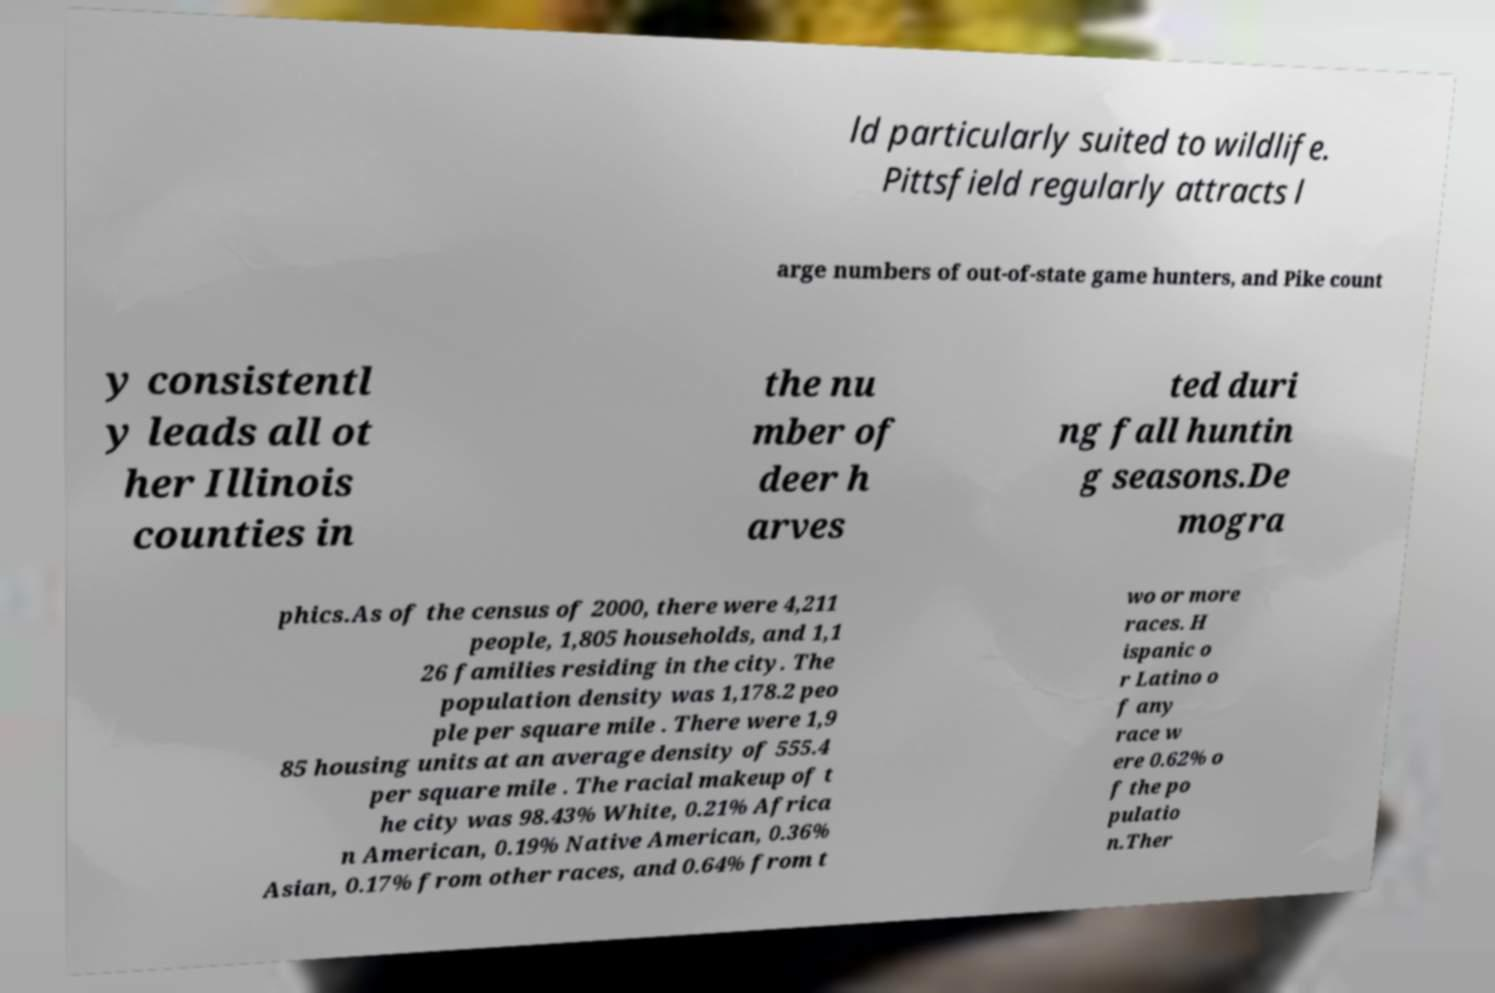I need the written content from this picture converted into text. Can you do that? ld particularly suited to wildlife. Pittsfield regularly attracts l arge numbers of out-of-state game hunters, and Pike count y consistentl y leads all ot her Illinois counties in the nu mber of deer h arves ted duri ng fall huntin g seasons.De mogra phics.As of the census of 2000, there were 4,211 people, 1,805 households, and 1,1 26 families residing in the city. The population density was 1,178.2 peo ple per square mile . There were 1,9 85 housing units at an average density of 555.4 per square mile . The racial makeup of t he city was 98.43% White, 0.21% Africa n American, 0.19% Native American, 0.36% Asian, 0.17% from other races, and 0.64% from t wo or more races. H ispanic o r Latino o f any race w ere 0.62% o f the po pulatio n.Ther 